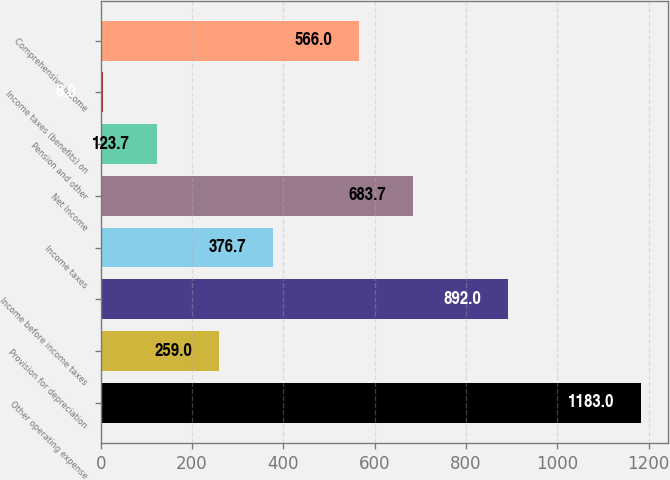Convert chart. <chart><loc_0><loc_0><loc_500><loc_500><bar_chart><fcel>Other operating expense<fcel>Provision for depreciation<fcel>Income before income taxes<fcel>Income taxes<fcel>Net Income<fcel>Pension and other<fcel>Income taxes (benefits) on<fcel>Comprehensive income<nl><fcel>1183<fcel>259<fcel>892<fcel>376.7<fcel>683.7<fcel>123.7<fcel>6<fcel>566<nl></chart> 